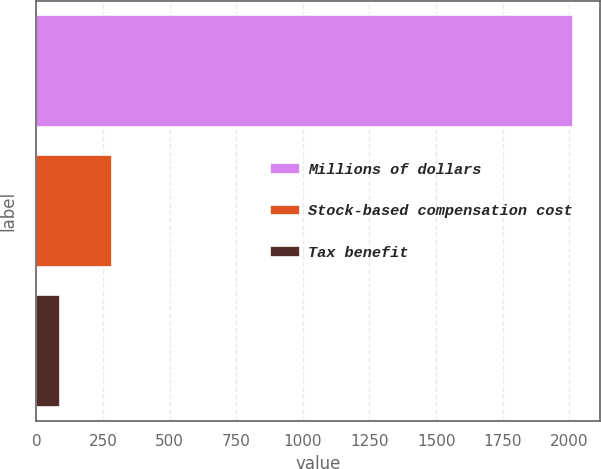Convert chart. <chart><loc_0><loc_0><loc_500><loc_500><bar_chart><fcel>Millions of dollars<fcel>Stock-based compensation cost<fcel>Tax benefit<nl><fcel>2014<fcel>282.4<fcel>90<nl></chart> 